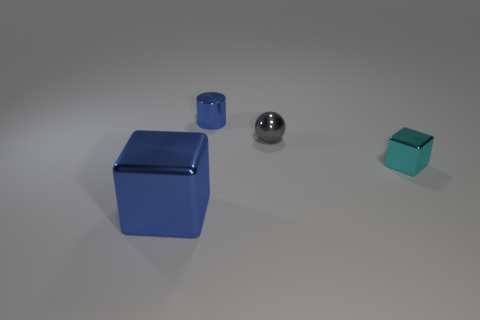Are all the objects on the same surface level? It appears that all the objects are resting on the same flat surface. There are no visible signs of elevation or indentation beneath any of the objects. Is the smaller blue cube the same color as the larger one? The smaller blue cube shares a similar color to the larger one, but due to the different scales and possibly the lighting, there might be a slight perceptible variation in hue. 